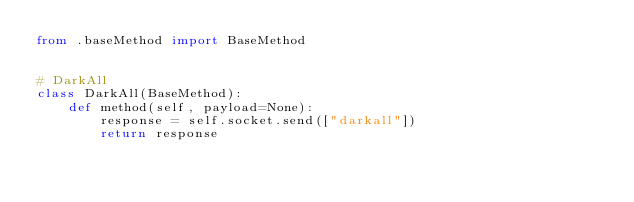<code> <loc_0><loc_0><loc_500><loc_500><_Python_>from .baseMethod import BaseMethod


# DarkAll
class DarkAll(BaseMethod):
    def method(self, payload=None):
        response = self.socket.send(["darkall"])
        return response
</code> 